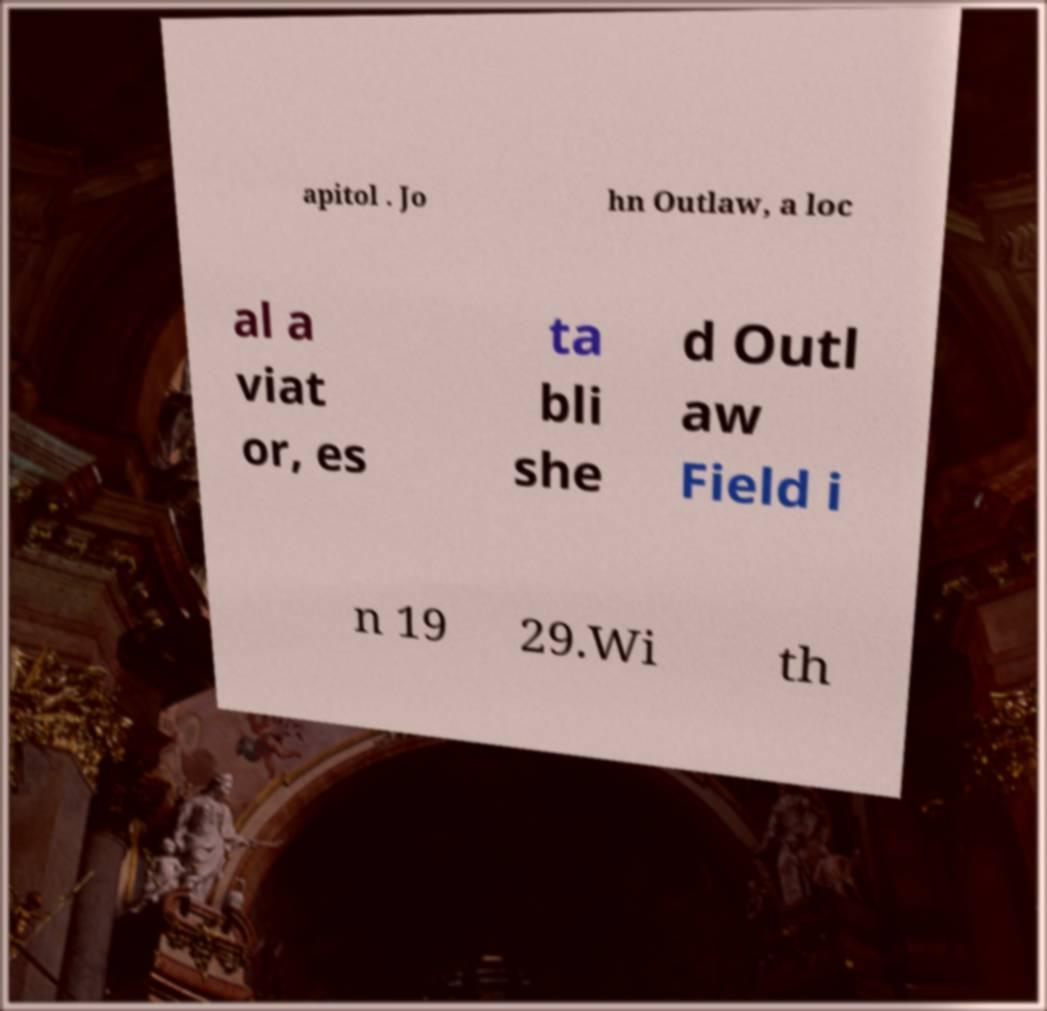Could you assist in decoding the text presented in this image and type it out clearly? apitol . Jo hn Outlaw, a loc al a viat or, es ta bli she d Outl aw Field i n 19 29.Wi th 